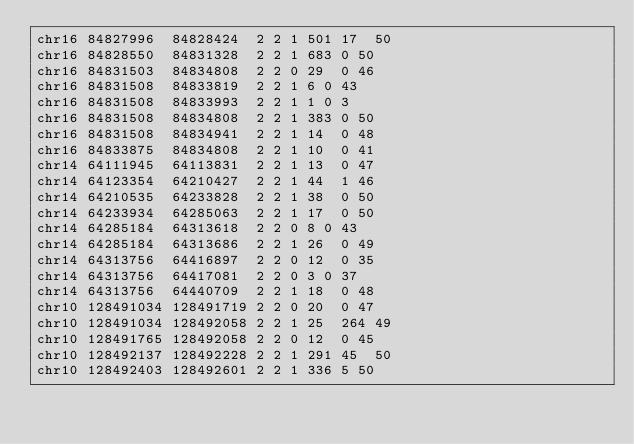Convert code to text. <code><loc_0><loc_0><loc_500><loc_500><_SQL_>chr16	84827996	84828424	2	2	1	501	17	50
chr16	84828550	84831328	2	2	1	683	0	50
chr16	84831503	84834808	2	2	0	29	0	46
chr16	84831508	84833819	2	2	1	6	0	43
chr16	84831508	84833993	2	2	1	1	0	3
chr16	84831508	84834808	2	2	1	383	0	50
chr16	84831508	84834941	2	2	1	14	0	48
chr16	84833875	84834808	2	2	1	10	0	41
chr14	64111945	64113831	2	2	1	13	0	47
chr14	64123354	64210427	2	2	1	44	1	46
chr14	64210535	64233828	2	2	1	38	0	50
chr14	64233934	64285063	2	2	1	17	0	50
chr14	64285184	64313618	2	2	0	8	0	43
chr14	64285184	64313686	2	2	1	26	0	49
chr14	64313756	64416897	2	2	0	12	0	35
chr14	64313756	64417081	2	2	0	3	0	37
chr14	64313756	64440709	2	2	1	18	0	48
chr10	128491034	128491719	2	2	0	20	0	47
chr10	128491034	128492058	2	2	1	25	264	49
chr10	128491765	128492058	2	2	0	12	0	45
chr10	128492137	128492228	2	2	1	291	45	50
chr10	128492403	128492601	2	2	1	336	5	50</code> 